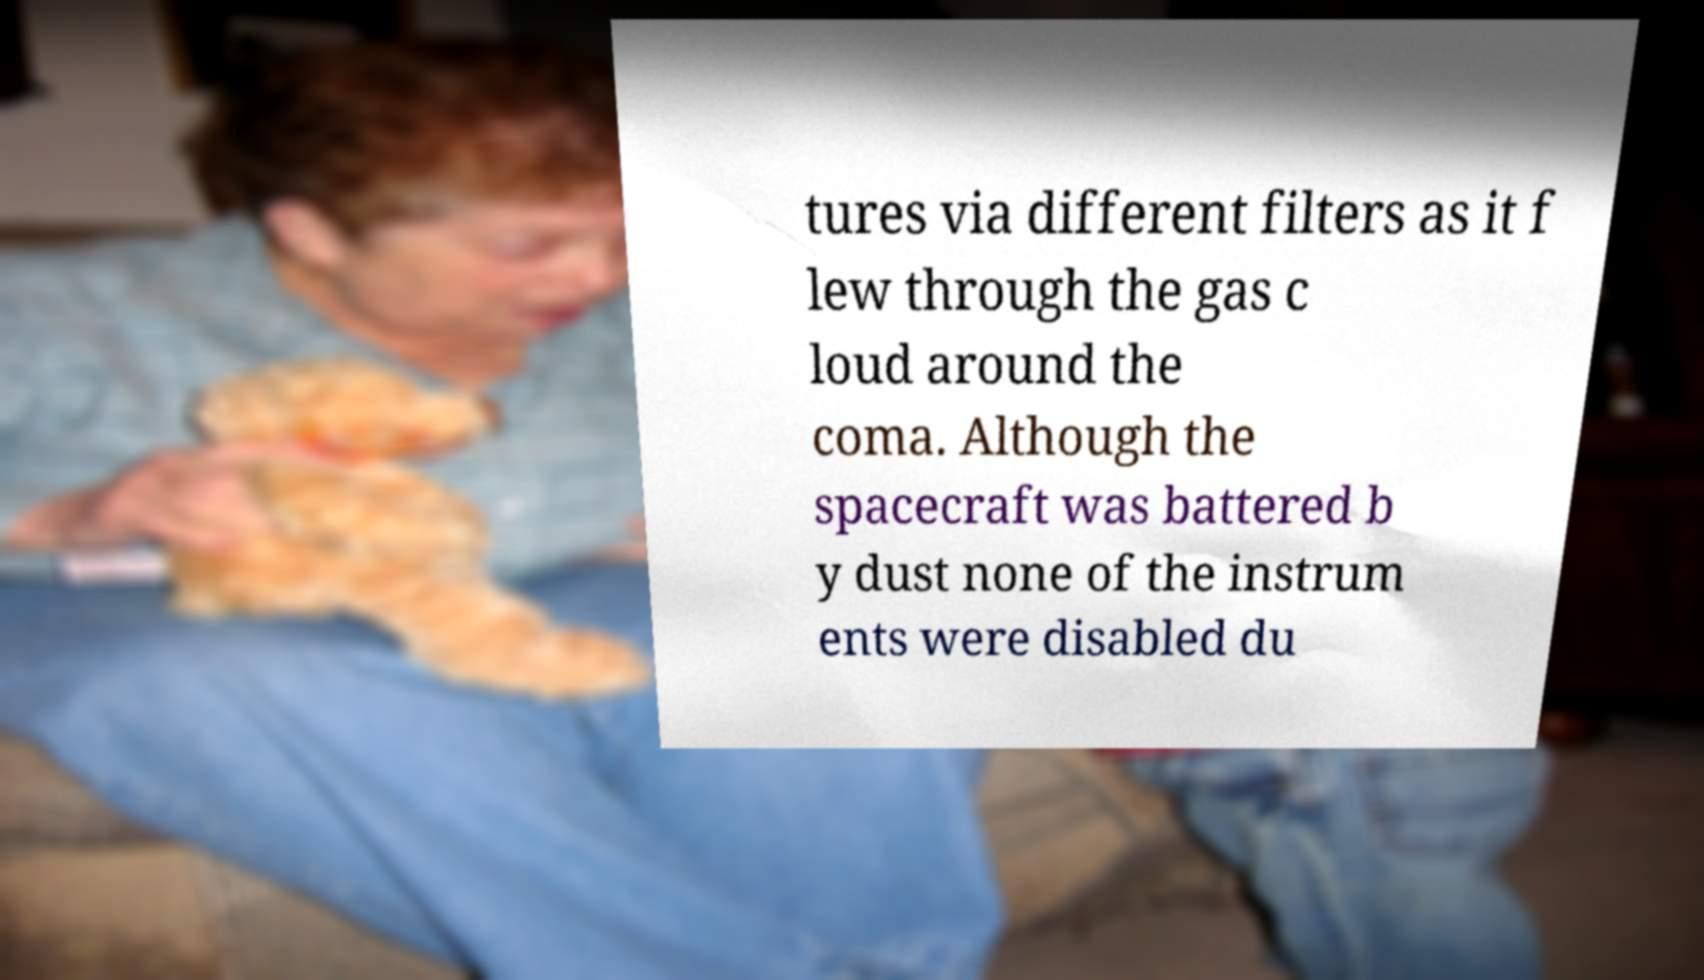Please read and relay the text visible in this image. What does it say? tures via different filters as it f lew through the gas c loud around the coma. Although the spacecraft was battered b y dust none of the instrum ents were disabled du 